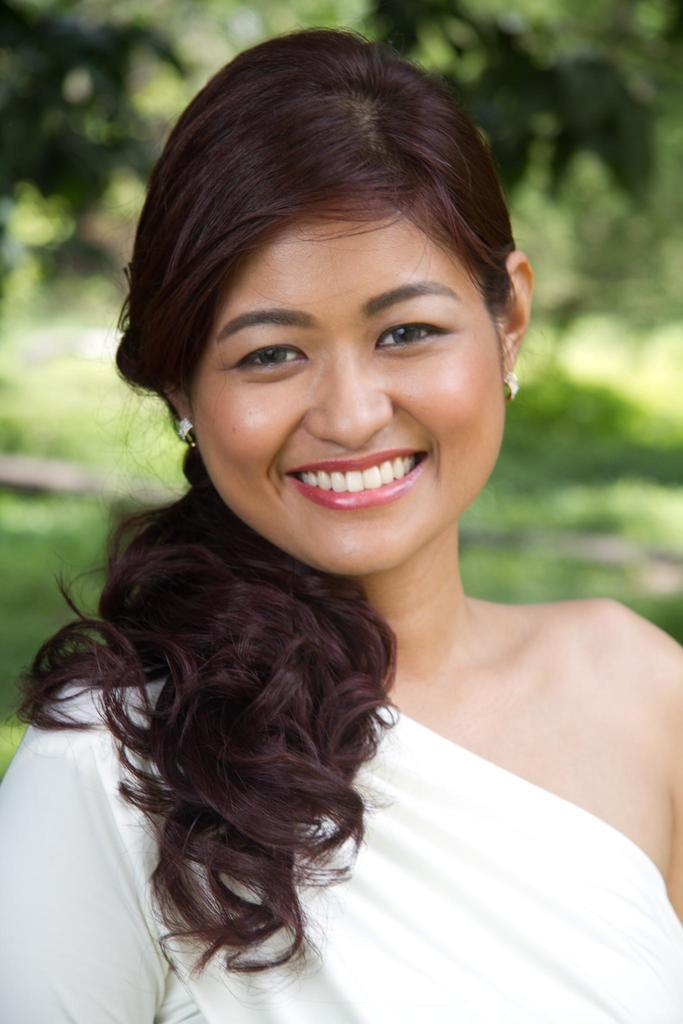Who is the main subject in the foreground of the image? There is a woman in the foreground of the image. What is the woman's facial expression in the image? The woman is smiling in the image. What can be seen in the background of the image? There are trees in the background of the image. What type of burn can be seen on the woman's arm in the image? There is no burn visible on the woman's arm in the image. What is the woman holding in her hand in the image? The provided facts do not mention what the woman is holding in her hand, if anything. 